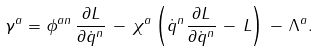<formula> <loc_0><loc_0><loc_500><loc_500>\gamma ^ { a } = \phi ^ { a n } \, \frac { \partial L } { \partial \dot { q } ^ { n } } \, - \, \chi ^ { a } \left ( \dot { q } ^ { n } \frac { \partial L } { \partial \dot { q } ^ { n } } \, - \, L \right ) \, - \, \Lambda ^ { a } .</formula> 